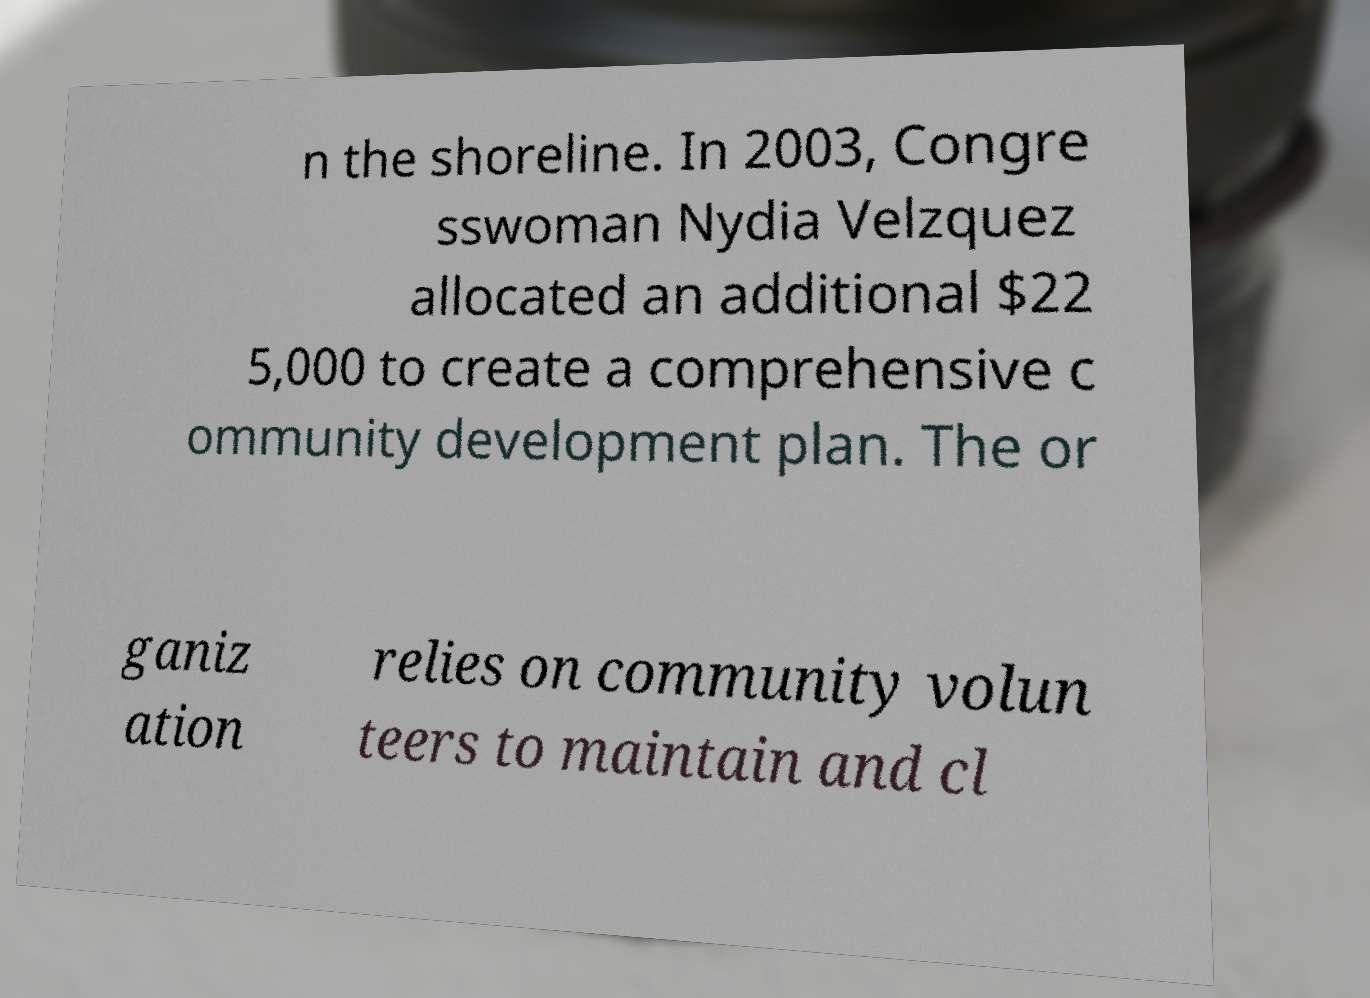I need the written content from this picture converted into text. Can you do that? n the shoreline. In 2003, Congre sswoman Nydia Velzquez allocated an additional $22 5,000 to create a comprehensive c ommunity development plan. The or ganiz ation relies on community volun teers to maintain and cl 